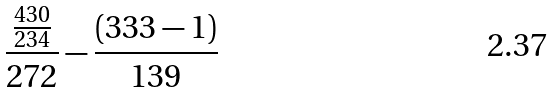Convert formula to latex. <formula><loc_0><loc_0><loc_500><loc_500>\frac { \frac { 4 3 0 } { 2 3 4 } } { 2 7 2 } - \frac { ( 3 3 3 - 1 ) } { 1 3 9 }</formula> 